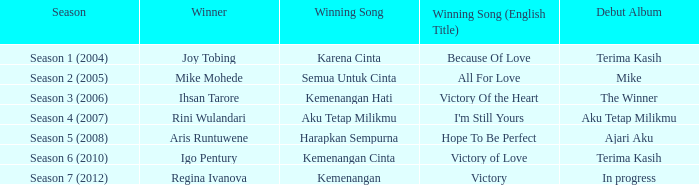Which triumphant song had a first album in development? Kemenangan. 